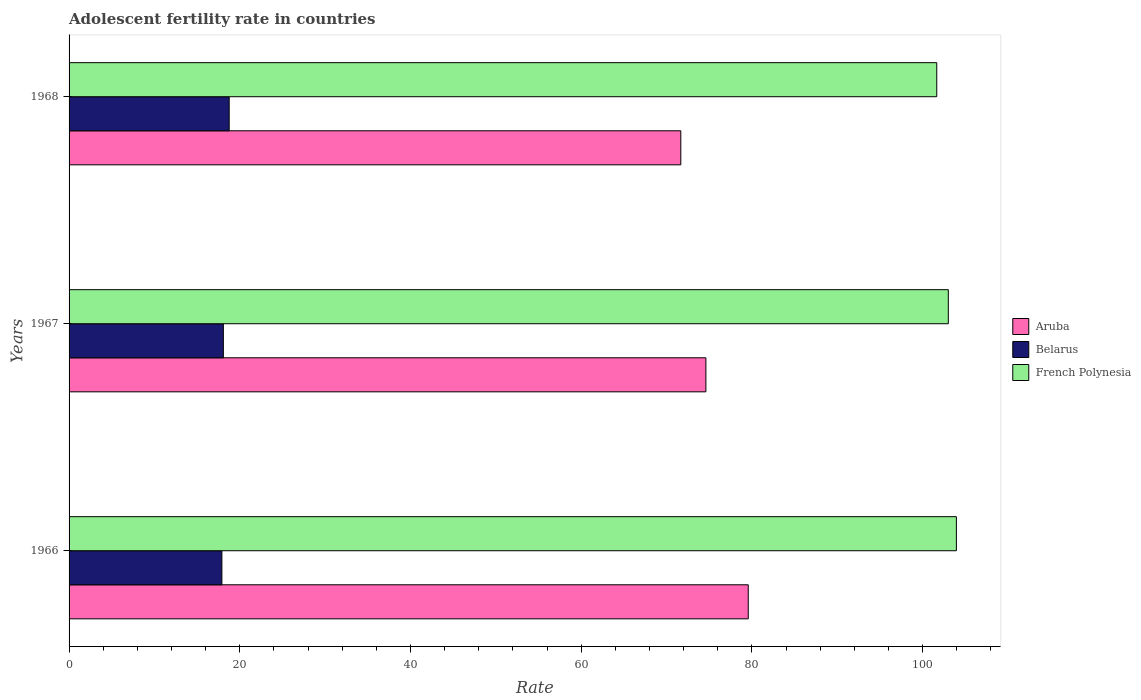How many different coloured bars are there?
Keep it short and to the point. 3. Are the number of bars per tick equal to the number of legend labels?
Offer a terse response. Yes. Are the number of bars on each tick of the Y-axis equal?
Provide a succinct answer. Yes. How many bars are there on the 3rd tick from the bottom?
Your answer should be very brief. 3. What is the label of the 3rd group of bars from the top?
Offer a very short reply. 1966. What is the adolescent fertility rate in Belarus in 1966?
Your response must be concise. 17.9. Across all years, what is the maximum adolescent fertility rate in Belarus?
Ensure brevity in your answer.  18.76. Across all years, what is the minimum adolescent fertility rate in Aruba?
Provide a short and direct response. 71.67. In which year was the adolescent fertility rate in French Polynesia maximum?
Offer a very short reply. 1966. In which year was the adolescent fertility rate in French Polynesia minimum?
Ensure brevity in your answer.  1968. What is the total adolescent fertility rate in Aruba in the graph?
Make the answer very short. 225.83. What is the difference between the adolescent fertility rate in French Polynesia in 1966 and that in 1968?
Ensure brevity in your answer.  2.3. What is the difference between the adolescent fertility rate in Belarus in 1966 and the adolescent fertility rate in Aruba in 1968?
Provide a short and direct response. -53.76. What is the average adolescent fertility rate in Belarus per year?
Give a very brief answer. 18.25. In the year 1967, what is the difference between the adolescent fertility rate in French Polynesia and adolescent fertility rate in Aruba?
Your answer should be compact. 28.4. In how many years, is the adolescent fertility rate in Belarus greater than 52 ?
Your response must be concise. 0. What is the ratio of the adolescent fertility rate in Belarus in 1967 to that in 1968?
Ensure brevity in your answer.  0.96. What is the difference between the highest and the second highest adolescent fertility rate in Belarus?
Provide a succinct answer. 0.68. What is the difference between the highest and the lowest adolescent fertility rate in Belarus?
Give a very brief answer. 0.85. What does the 3rd bar from the top in 1968 represents?
Your answer should be compact. Aruba. What does the 2nd bar from the bottom in 1968 represents?
Give a very brief answer. Belarus. What is the difference between two consecutive major ticks on the X-axis?
Keep it short and to the point. 20. Are the values on the major ticks of X-axis written in scientific E-notation?
Your answer should be compact. No. Where does the legend appear in the graph?
Make the answer very short. Center right. How many legend labels are there?
Offer a very short reply. 3. How are the legend labels stacked?
Ensure brevity in your answer.  Vertical. What is the title of the graph?
Provide a short and direct response. Adolescent fertility rate in countries. Does "Luxembourg" appear as one of the legend labels in the graph?
Provide a succinct answer. No. What is the label or title of the X-axis?
Your answer should be very brief. Rate. What is the Rate of Aruba in 1966?
Your response must be concise. 79.57. What is the Rate of Belarus in 1966?
Your response must be concise. 17.9. What is the Rate of French Polynesia in 1966?
Your response must be concise. 103.95. What is the Rate in Aruba in 1967?
Give a very brief answer. 74.6. What is the Rate of Belarus in 1967?
Make the answer very short. 18.07. What is the Rate of French Polynesia in 1967?
Give a very brief answer. 103. What is the Rate in Aruba in 1968?
Your answer should be very brief. 71.67. What is the Rate of Belarus in 1968?
Give a very brief answer. 18.76. What is the Rate of French Polynesia in 1968?
Make the answer very short. 101.65. Across all years, what is the maximum Rate in Aruba?
Keep it short and to the point. 79.57. Across all years, what is the maximum Rate of Belarus?
Give a very brief answer. 18.76. Across all years, what is the maximum Rate in French Polynesia?
Offer a very short reply. 103.95. Across all years, what is the minimum Rate of Aruba?
Keep it short and to the point. 71.67. Across all years, what is the minimum Rate of Belarus?
Make the answer very short. 17.9. Across all years, what is the minimum Rate of French Polynesia?
Offer a very short reply. 101.65. What is the total Rate in Aruba in the graph?
Provide a short and direct response. 225.83. What is the total Rate of Belarus in the graph?
Offer a very short reply. 54.73. What is the total Rate of French Polynesia in the graph?
Offer a terse response. 308.6. What is the difference between the Rate in Aruba in 1966 and that in 1967?
Your answer should be compact. 4.96. What is the difference between the Rate in Belarus in 1966 and that in 1967?
Keep it short and to the point. -0.17. What is the difference between the Rate in French Polynesia in 1966 and that in 1967?
Your answer should be compact. 0.95. What is the difference between the Rate in Aruba in 1966 and that in 1968?
Your answer should be very brief. 7.9. What is the difference between the Rate of Belarus in 1966 and that in 1968?
Give a very brief answer. -0.85. What is the difference between the Rate of French Polynesia in 1966 and that in 1968?
Provide a succinct answer. 2.3. What is the difference between the Rate of Aruba in 1967 and that in 1968?
Offer a very short reply. 2.94. What is the difference between the Rate of Belarus in 1967 and that in 1968?
Your answer should be very brief. -0.68. What is the difference between the Rate of French Polynesia in 1967 and that in 1968?
Give a very brief answer. 1.35. What is the difference between the Rate of Aruba in 1966 and the Rate of Belarus in 1967?
Keep it short and to the point. 61.49. What is the difference between the Rate of Aruba in 1966 and the Rate of French Polynesia in 1967?
Offer a terse response. -23.44. What is the difference between the Rate in Belarus in 1966 and the Rate in French Polynesia in 1967?
Keep it short and to the point. -85.1. What is the difference between the Rate of Aruba in 1966 and the Rate of Belarus in 1968?
Make the answer very short. 60.81. What is the difference between the Rate of Aruba in 1966 and the Rate of French Polynesia in 1968?
Your answer should be compact. -22.08. What is the difference between the Rate of Belarus in 1966 and the Rate of French Polynesia in 1968?
Give a very brief answer. -83.75. What is the difference between the Rate of Aruba in 1967 and the Rate of Belarus in 1968?
Offer a terse response. 55.85. What is the difference between the Rate of Aruba in 1967 and the Rate of French Polynesia in 1968?
Provide a succinct answer. -27.05. What is the difference between the Rate in Belarus in 1967 and the Rate in French Polynesia in 1968?
Provide a succinct answer. -83.57. What is the average Rate in Aruba per year?
Give a very brief answer. 75.28. What is the average Rate of Belarus per year?
Your answer should be compact. 18.25. What is the average Rate of French Polynesia per year?
Provide a succinct answer. 102.87. In the year 1966, what is the difference between the Rate in Aruba and Rate in Belarus?
Offer a terse response. 61.66. In the year 1966, what is the difference between the Rate of Aruba and Rate of French Polynesia?
Your answer should be very brief. -24.38. In the year 1966, what is the difference between the Rate in Belarus and Rate in French Polynesia?
Offer a very short reply. -86.05. In the year 1967, what is the difference between the Rate of Aruba and Rate of Belarus?
Make the answer very short. 56.53. In the year 1967, what is the difference between the Rate in Aruba and Rate in French Polynesia?
Your answer should be compact. -28.4. In the year 1967, what is the difference between the Rate of Belarus and Rate of French Polynesia?
Make the answer very short. -84.93. In the year 1968, what is the difference between the Rate in Aruba and Rate in Belarus?
Keep it short and to the point. 52.91. In the year 1968, what is the difference between the Rate of Aruba and Rate of French Polynesia?
Your answer should be compact. -29.98. In the year 1968, what is the difference between the Rate in Belarus and Rate in French Polynesia?
Your answer should be very brief. -82.89. What is the ratio of the Rate in Aruba in 1966 to that in 1967?
Provide a short and direct response. 1.07. What is the ratio of the Rate in Belarus in 1966 to that in 1967?
Your response must be concise. 0.99. What is the ratio of the Rate of French Polynesia in 1966 to that in 1967?
Your answer should be compact. 1.01. What is the ratio of the Rate in Aruba in 1966 to that in 1968?
Offer a terse response. 1.11. What is the ratio of the Rate of Belarus in 1966 to that in 1968?
Make the answer very short. 0.95. What is the ratio of the Rate in French Polynesia in 1966 to that in 1968?
Your answer should be very brief. 1.02. What is the ratio of the Rate in Aruba in 1967 to that in 1968?
Make the answer very short. 1.04. What is the ratio of the Rate in Belarus in 1967 to that in 1968?
Keep it short and to the point. 0.96. What is the ratio of the Rate in French Polynesia in 1967 to that in 1968?
Ensure brevity in your answer.  1.01. What is the difference between the highest and the second highest Rate in Aruba?
Your answer should be compact. 4.96. What is the difference between the highest and the second highest Rate in Belarus?
Give a very brief answer. 0.68. What is the difference between the highest and the lowest Rate in Aruba?
Give a very brief answer. 7.9. What is the difference between the highest and the lowest Rate in Belarus?
Ensure brevity in your answer.  0.85. What is the difference between the highest and the lowest Rate in French Polynesia?
Ensure brevity in your answer.  2.3. 